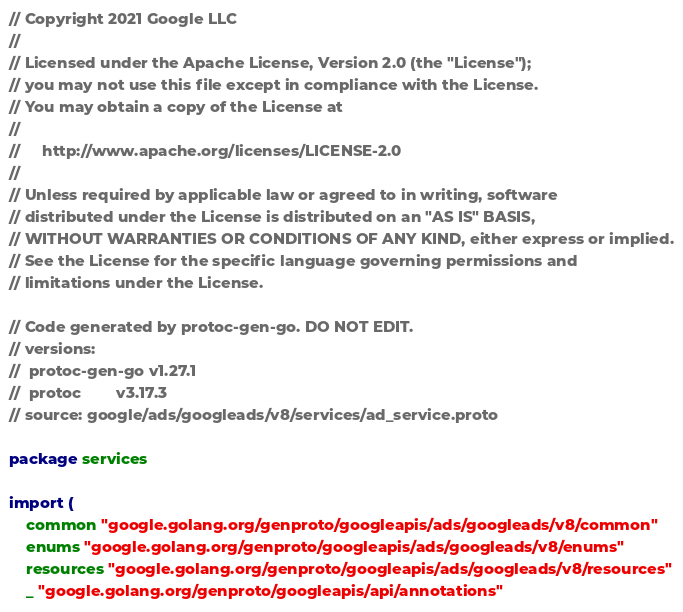Convert code to text. <code><loc_0><loc_0><loc_500><loc_500><_Go_>// Copyright 2021 Google LLC
//
// Licensed under the Apache License, Version 2.0 (the "License");
// you may not use this file except in compliance with the License.
// You may obtain a copy of the License at
//
//     http://www.apache.org/licenses/LICENSE-2.0
//
// Unless required by applicable law or agreed to in writing, software
// distributed under the License is distributed on an "AS IS" BASIS,
// WITHOUT WARRANTIES OR CONDITIONS OF ANY KIND, either express or implied.
// See the License for the specific language governing permissions and
// limitations under the License.

// Code generated by protoc-gen-go. DO NOT EDIT.
// versions:
// 	protoc-gen-go v1.27.1
// 	protoc        v3.17.3
// source: google/ads/googleads/v8/services/ad_service.proto

package services

import (
	common "google.golang.org/genproto/googleapis/ads/googleads/v8/common"
	enums "google.golang.org/genproto/googleapis/ads/googleads/v8/enums"
	resources "google.golang.org/genproto/googleapis/ads/googleads/v8/resources"
	_ "google.golang.org/genproto/googleapis/api/annotations"</code> 